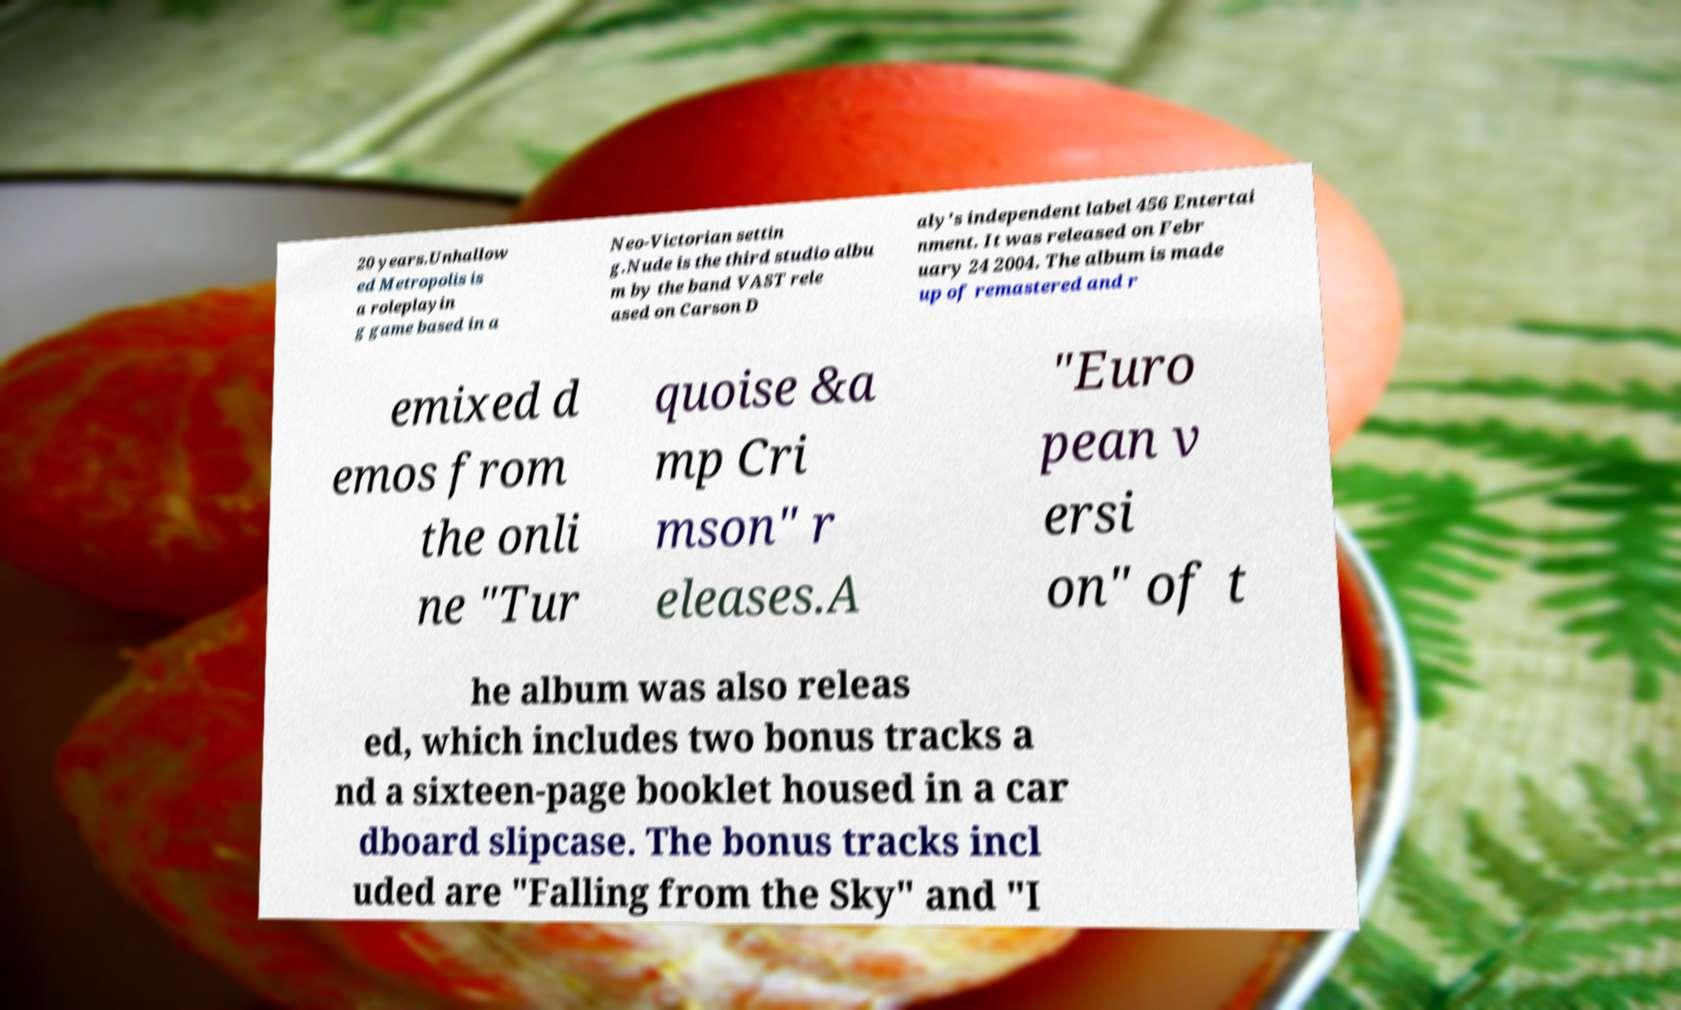For documentation purposes, I need the text within this image transcribed. Could you provide that? 20 years.Unhallow ed Metropolis is a roleplayin g game based in a Neo-Victorian settin g.Nude is the third studio albu m by the band VAST rele ased on Carson D aly's independent label 456 Entertai nment. It was released on Febr uary 24 2004. The album is made up of remastered and r emixed d emos from the onli ne "Tur quoise &a mp Cri mson" r eleases.A "Euro pean v ersi on" of t he album was also releas ed, which includes two bonus tracks a nd a sixteen-page booklet housed in a car dboard slipcase. The bonus tracks incl uded are "Falling from the Sky" and "I 